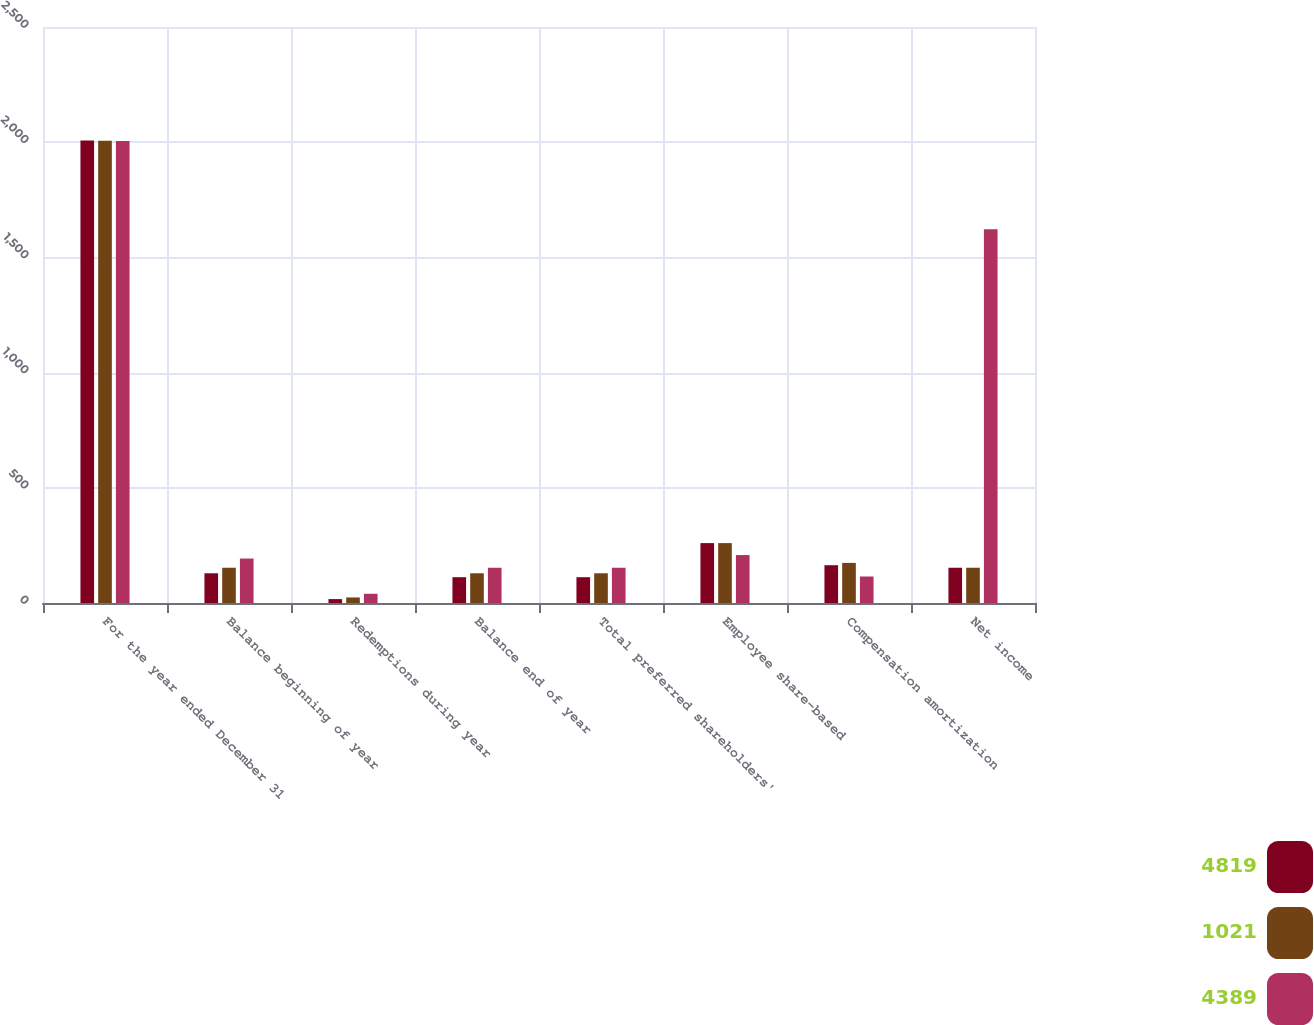Convert chart. <chart><loc_0><loc_0><loc_500><loc_500><stacked_bar_chart><ecel><fcel>For the year ended December 31<fcel>Balance beginning of year<fcel>Redemptions during year<fcel>Balance end of year<fcel>Total preferred shareholders'<fcel>Employee share-based<fcel>Compensation amortization<fcel>Net income<nl><fcel>4819<fcel>2007<fcel>129<fcel>17<fcel>112<fcel>112<fcel>260<fcel>164<fcel>153<nl><fcel>1021<fcel>2006<fcel>153<fcel>24<fcel>129<fcel>129<fcel>260<fcel>174<fcel>153<nl><fcel>4389<fcel>2005<fcel>193<fcel>40<fcel>153<fcel>153<fcel>208<fcel>115<fcel>1622<nl></chart> 